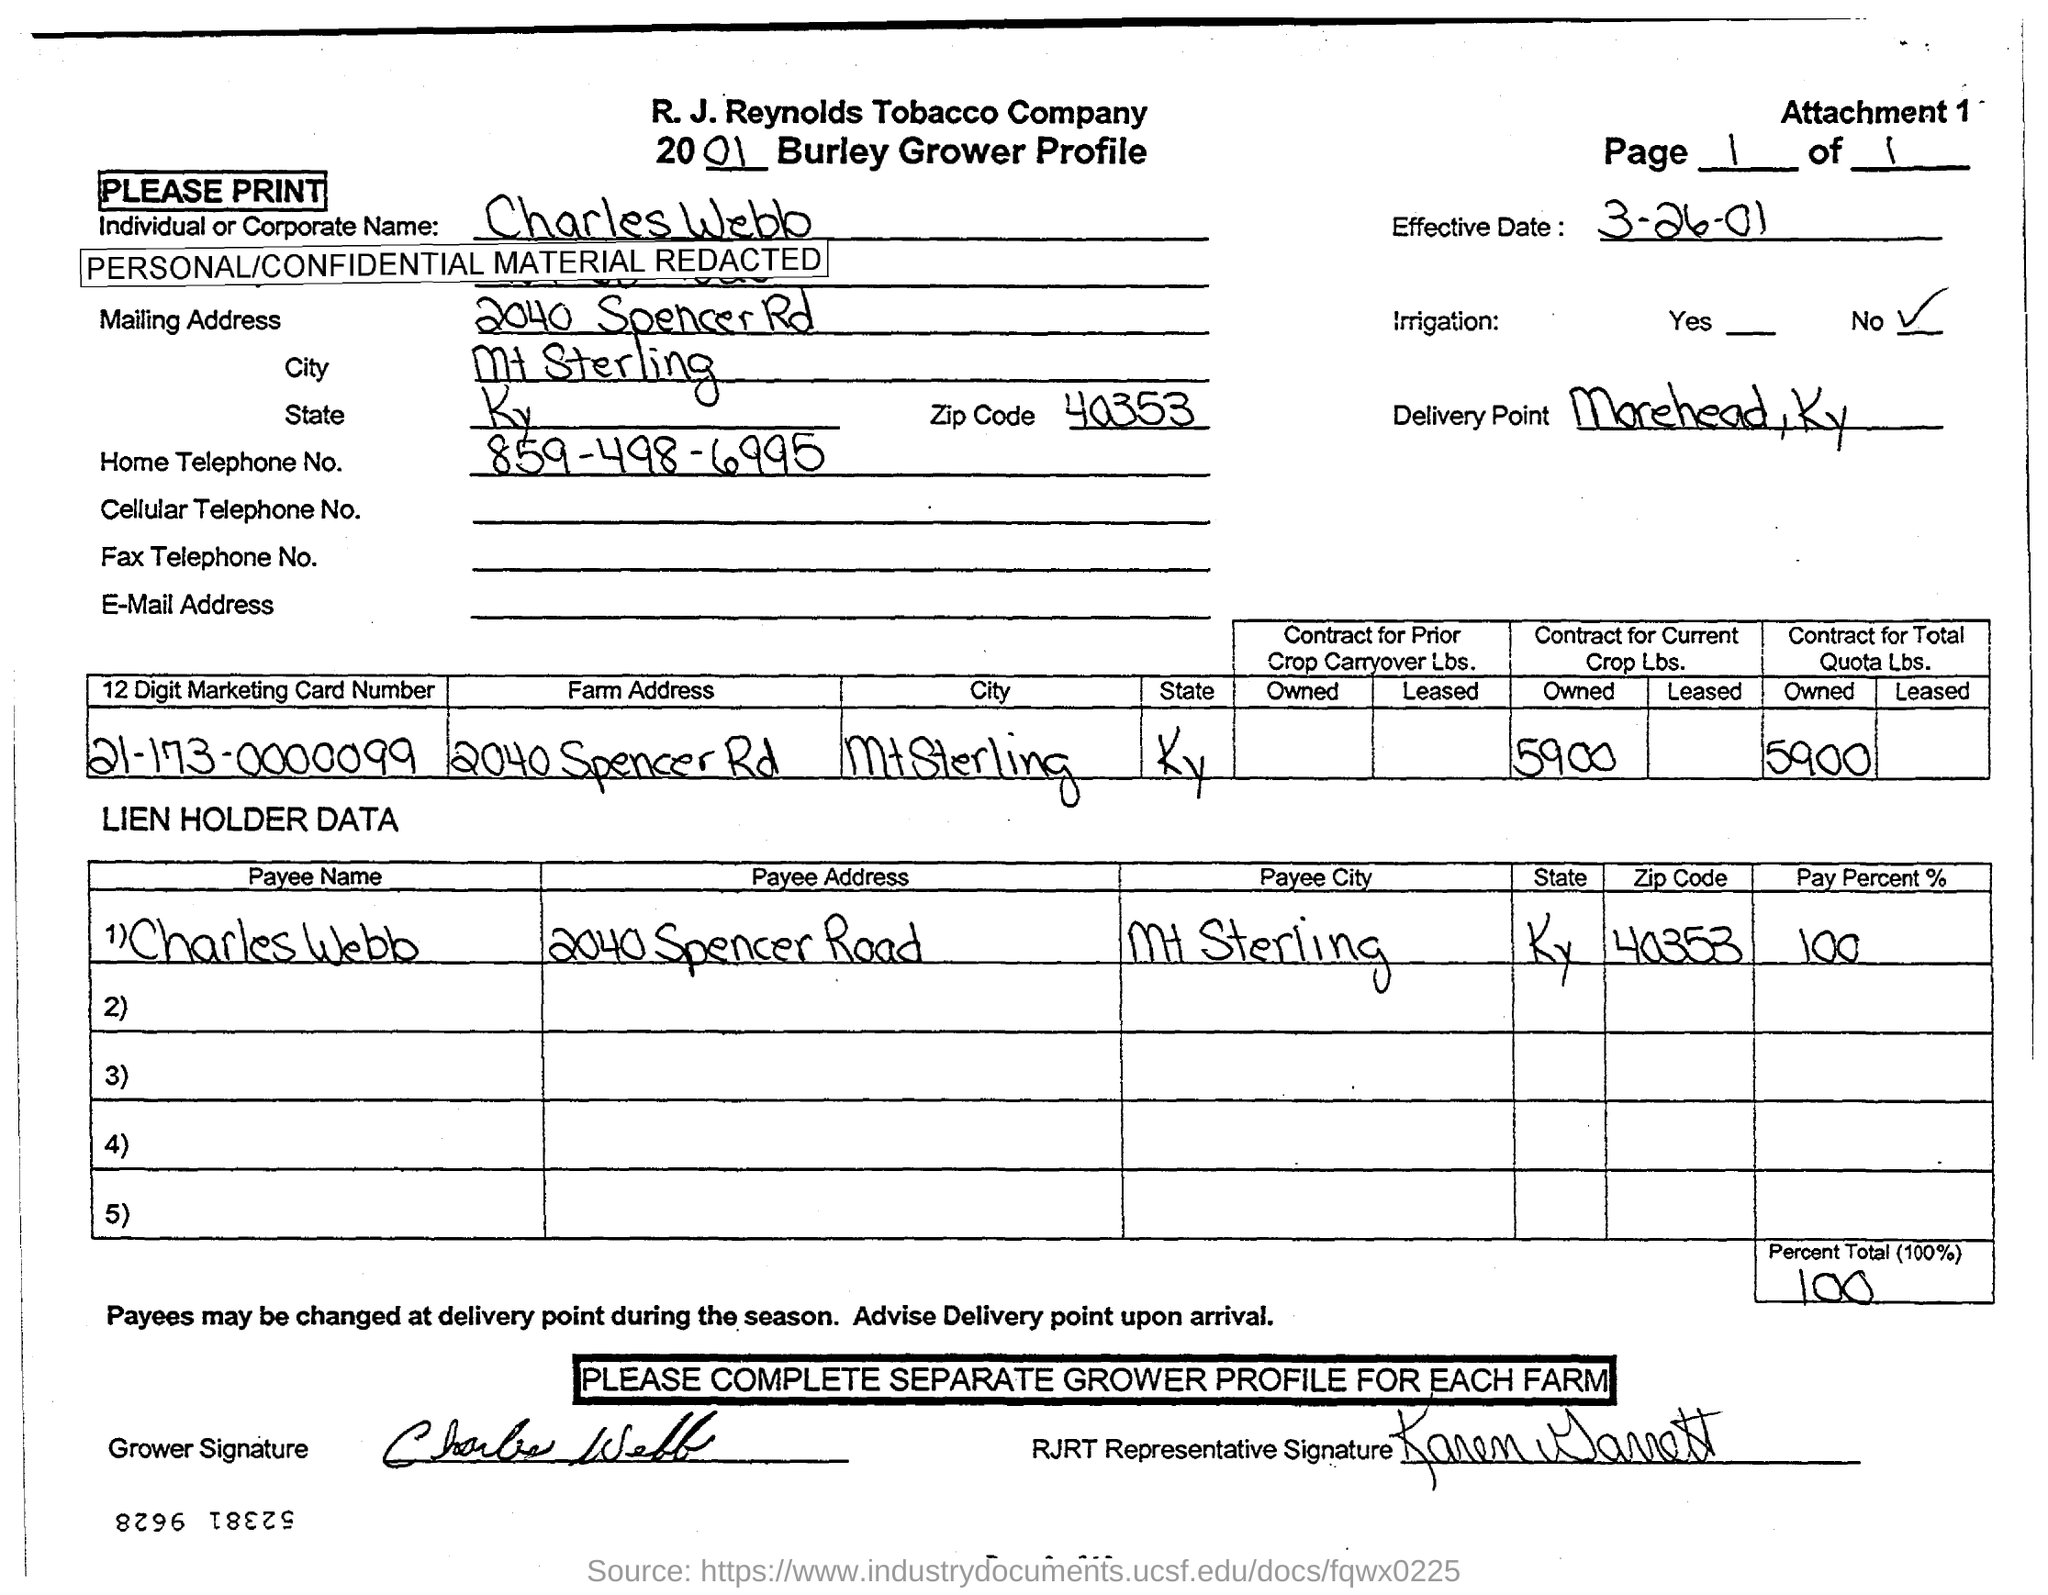List a handful of essential elements in this visual. What is the City? It is located in Mt Sterling. The home telephone number is 859-498-6995. The payee address is 2040 Spencer Road. The payee name is "Charles Webb. 